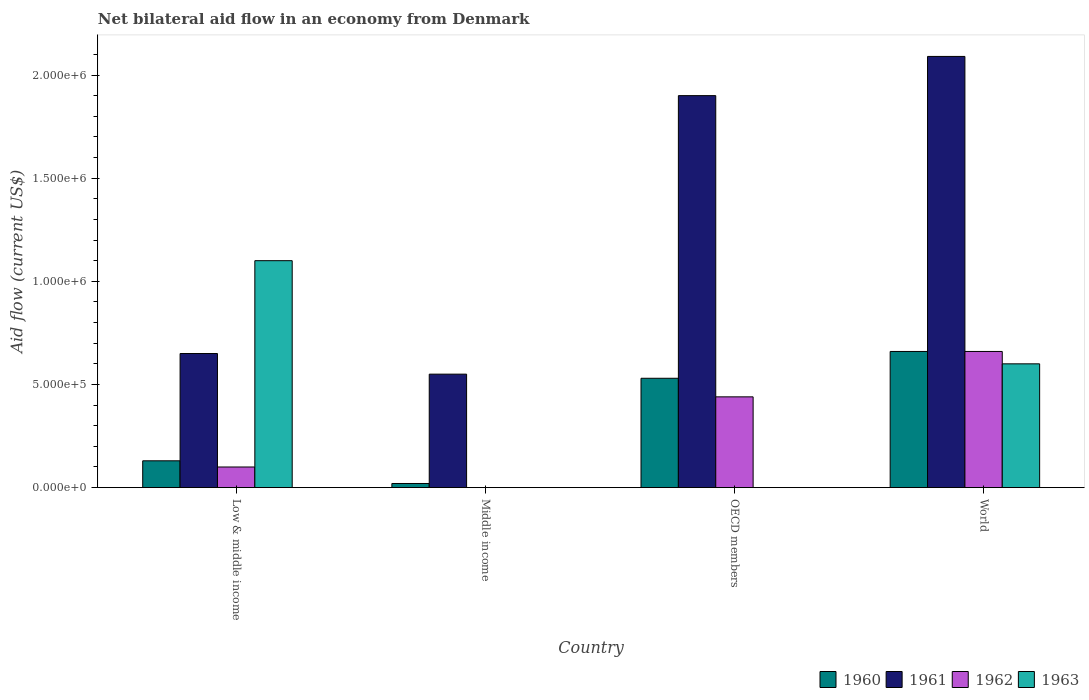How many different coloured bars are there?
Your answer should be very brief. 4. How many groups of bars are there?
Offer a terse response. 4. Are the number of bars per tick equal to the number of legend labels?
Ensure brevity in your answer.  No. Are the number of bars on each tick of the X-axis equal?
Provide a short and direct response. No. How many bars are there on the 3rd tick from the right?
Offer a terse response. 2. What is the label of the 2nd group of bars from the left?
Provide a short and direct response. Middle income. What is the net bilateral aid flow in 1963 in World?
Provide a succinct answer. 6.00e+05. Across all countries, what is the maximum net bilateral aid flow in 1963?
Provide a succinct answer. 1.10e+06. In which country was the net bilateral aid flow in 1960 maximum?
Your response must be concise. World. What is the total net bilateral aid flow in 1961 in the graph?
Ensure brevity in your answer.  5.19e+06. What is the difference between the net bilateral aid flow in 1960 in Low & middle income and that in OECD members?
Your response must be concise. -4.00e+05. What is the difference between the net bilateral aid flow in 1962 in Low & middle income and the net bilateral aid flow in 1963 in World?
Give a very brief answer. -5.00e+05. What is the difference between the net bilateral aid flow of/in 1962 and net bilateral aid flow of/in 1960 in OECD members?
Provide a short and direct response. -9.00e+04. In how many countries, is the net bilateral aid flow in 1962 greater than 600000 US$?
Your answer should be very brief. 1. What is the ratio of the net bilateral aid flow in 1961 in Middle income to that in OECD members?
Offer a very short reply. 0.29. What is the difference between the highest and the second highest net bilateral aid flow in 1960?
Keep it short and to the point. 1.30e+05. What is the difference between the highest and the lowest net bilateral aid flow in 1961?
Keep it short and to the point. 1.54e+06. In how many countries, is the net bilateral aid flow in 1961 greater than the average net bilateral aid flow in 1961 taken over all countries?
Keep it short and to the point. 2. Is the sum of the net bilateral aid flow in 1960 in Low & middle income and OECD members greater than the maximum net bilateral aid flow in 1963 across all countries?
Ensure brevity in your answer.  No. How many bars are there?
Provide a succinct answer. 13. Are all the bars in the graph horizontal?
Offer a terse response. No. How many countries are there in the graph?
Keep it short and to the point. 4. What is the difference between two consecutive major ticks on the Y-axis?
Your response must be concise. 5.00e+05. How are the legend labels stacked?
Offer a very short reply. Horizontal. What is the title of the graph?
Make the answer very short. Net bilateral aid flow in an economy from Denmark. What is the label or title of the Y-axis?
Offer a very short reply. Aid flow (current US$). What is the Aid flow (current US$) of 1960 in Low & middle income?
Ensure brevity in your answer.  1.30e+05. What is the Aid flow (current US$) of 1961 in Low & middle income?
Provide a succinct answer. 6.50e+05. What is the Aid flow (current US$) of 1963 in Low & middle income?
Offer a very short reply. 1.10e+06. What is the Aid flow (current US$) in 1960 in Middle income?
Give a very brief answer. 2.00e+04. What is the Aid flow (current US$) of 1961 in Middle income?
Make the answer very short. 5.50e+05. What is the Aid flow (current US$) in 1962 in Middle income?
Offer a very short reply. 0. What is the Aid flow (current US$) of 1960 in OECD members?
Provide a succinct answer. 5.30e+05. What is the Aid flow (current US$) of 1961 in OECD members?
Your answer should be compact. 1.90e+06. What is the Aid flow (current US$) in 1963 in OECD members?
Provide a short and direct response. 0. What is the Aid flow (current US$) of 1960 in World?
Your answer should be very brief. 6.60e+05. What is the Aid flow (current US$) of 1961 in World?
Ensure brevity in your answer.  2.09e+06. What is the Aid flow (current US$) in 1962 in World?
Offer a terse response. 6.60e+05. What is the Aid flow (current US$) in 1963 in World?
Your answer should be compact. 6.00e+05. Across all countries, what is the maximum Aid flow (current US$) in 1961?
Your answer should be compact. 2.09e+06. Across all countries, what is the maximum Aid flow (current US$) in 1963?
Make the answer very short. 1.10e+06. Across all countries, what is the minimum Aid flow (current US$) in 1961?
Provide a succinct answer. 5.50e+05. Across all countries, what is the minimum Aid flow (current US$) of 1962?
Offer a terse response. 0. What is the total Aid flow (current US$) in 1960 in the graph?
Provide a short and direct response. 1.34e+06. What is the total Aid flow (current US$) of 1961 in the graph?
Provide a succinct answer. 5.19e+06. What is the total Aid flow (current US$) in 1962 in the graph?
Your answer should be very brief. 1.20e+06. What is the total Aid flow (current US$) in 1963 in the graph?
Offer a terse response. 1.70e+06. What is the difference between the Aid flow (current US$) of 1961 in Low & middle income and that in Middle income?
Offer a terse response. 1.00e+05. What is the difference between the Aid flow (current US$) in 1960 in Low & middle income and that in OECD members?
Keep it short and to the point. -4.00e+05. What is the difference between the Aid flow (current US$) in 1961 in Low & middle income and that in OECD members?
Make the answer very short. -1.25e+06. What is the difference between the Aid flow (current US$) of 1960 in Low & middle income and that in World?
Your answer should be compact. -5.30e+05. What is the difference between the Aid flow (current US$) of 1961 in Low & middle income and that in World?
Your answer should be compact. -1.44e+06. What is the difference between the Aid flow (current US$) of 1962 in Low & middle income and that in World?
Give a very brief answer. -5.60e+05. What is the difference between the Aid flow (current US$) of 1960 in Middle income and that in OECD members?
Ensure brevity in your answer.  -5.10e+05. What is the difference between the Aid flow (current US$) in 1961 in Middle income and that in OECD members?
Give a very brief answer. -1.35e+06. What is the difference between the Aid flow (current US$) of 1960 in Middle income and that in World?
Your answer should be very brief. -6.40e+05. What is the difference between the Aid flow (current US$) in 1961 in Middle income and that in World?
Keep it short and to the point. -1.54e+06. What is the difference between the Aid flow (current US$) of 1960 in Low & middle income and the Aid flow (current US$) of 1961 in Middle income?
Provide a short and direct response. -4.20e+05. What is the difference between the Aid flow (current US$) in 1960 in Low & middle income and the Aid flow (current US$) in 1961 in OECD members?
Your answer should be very brief. -1.77e+06. What is the difference between the Aid flow (current US$) of 1960 in Low & middle income and the Aid flow (current US$) of 1962 in OECD members?
Offer a very short reply. -3.10e+05. What is the difference between the Aid flow (current US$) in 1960 in Low & middle income and the Aid flow (current US$) in 1961 in World?
Offer a terse response. -1.96e+06. What is the difference between the Aid flow (current US$) in 1960 in Low & middle income and the Aid flow (current US$) in 1962 in World?
Your answer should be compact. -5.30e+05. What is the difference between the Aid flow (current US$) in 1960 in Low & middle income and the Aid flow (current US$) in 1963 in World?
Provide a short and direct response. -4.70e+05. What is the difference between the Aid flow (current US$) in 1961 in Low & middle income and the Aid flow (current US$) in 1963 in World?
Give a very brief answer. 5.00e+04. What is the difference between the Aid flow (current US$) of 1962 in Low & middle income and the Aid flow (current US$) of 1963 in World?
Keep it short and to the point. -5.00e+05. What is the difference between the Aid flow (current US$) in 1960 in Middle income and the Aid flow (current US$) in 1961 in OECD members?
Keep it short and to the point. -1.88e+06. What is the difference between the Aid flow (current US$) of 1960 in Middle income and the Aid flow (current US$) of 1962 in OECD members?
Your answer should be compact. -4.20e+05. What is the difference between the Aid flow (current US$) of 1961 in Middle income and the Aid flow (current US$) of 1962 in OECD members?
Make the answer very short. 1.10e+05. What is the difference between the Aid flow (current US$) of 1960 in Middle income and the Aid flow (current US$) of 1961 in World?
Keep it short and to the point. -2.07e+06. What is the difference between the Aid flow (current US$) of 1960 in Middle income and the Aid flow (current US$) of 1962 in World?
Your answer should be very brief. -6.40e+05. What is the difference between the Aid flow (current US$) of 1960 in Middle income and the Aid flow (current US$) of 1963 in World?
Offer a terse response. -5.80e+05. What is the difference between the Aid flow (current US$) in 1961 in Middle income and the Aid flow (current US$) in 1963 in World?
Provide a succinct answer. -5.00e+04. What is the difference between the Aid flow (current US$) of 1960 in OECD members and the Aid flow (current US$) of 1961 in World?
Your answer should be compact. -1.56e+06. What is the difference between the Aid flow (current US$) of 1960 in OECD members and the Aid flow (current US$) of 1962 in World?
Ensure brevity in your answer.  -1.30e+05. What is the difference between the Aid flow (current US$) in 1960 in OECD members and the Aid flow (current US$) in 1963 in World?
Your answer should be compact. -7.00e+04. What is the difference between the Aid flow (current US$) in 1961 in OECD members and the Aid flow (current US$) in 1962 in World?
Keep it short and to the point. 1.24e+06. What is the difference between the Aid flow (current US$) of 1961 in OECD members and the Aid flow (current US$) of 1963 in World?
Give a very brief answer. 1.30e+06. What is the average Aid flow (current US$) in 1960 per country?
Give a very brief answer. 3.35e+05. What is the average Aid flow (current US$) in 1961 per country?
Your response must be concise. 1.30e+06. What is the average Aid flow (current US$) of 1963 per country?
Keep it short and to the point. 4.25e+05. What is the difference between the Aid flow (current US$) of 1960 and Aid flow (current US$) of 1961 in Low & middle income?
Make the answer very short. -5.20e+05. What is the difference between the Aid flow (current US$) in 1960 and Aid flow (current US$) in 1963 in Low & middle income?
Your answer should be very brief. -9.70e+05. What is the difference between the Aid flow (current US$) of 1961 and Aid flow (current US$) of 1963 in Low & middle income?
Offer a very short reply. -4.50e+05. What is the difference between the Aid flow (current US$) in 1960 and Aid flow (current US$) in 1961 in Middle income?
Offer a terse response. -5.30e+05. What is the difference between the Aid flow (current US$) in 1960 and Aid flow (current US$) in 1961 in OECD members?
Provide a short and direct response. -1.37e+06. What is the difference between the Aid flow (current US$) in 1961 and Aid flow (current US$) in 1962 in OECD members?
Your answer should be compact. 1.46e+06. What is the difference between the Aid flow (current US$) of 1960 and Aid flow (current US$) of 1961 in World?
Provide a succinct answer. -1.43e+06. What is the difference between the Aid flow (current US$) in 1960 and Aid flow (current US$) in 1962 in World?
Give a very brief answer. 0. What is the difference between the Aid flow (current US$) of 1961 and Aid flow (current US$) of 1962 in World?
Keep it short and to the point. 1.43e+06. What is the difference between the Aid flow (current US$) of 1961 and Aid flow (current US$) of 1963 in World?
Give a very brief answer. 1.49e+06. What is the ratio of the Aid flow (current US$) in 1960 in Low & middle income to that in Middle income?
Provide a short and direct response. 6.5. What is the ratio of the Aid flow (current US$) in 1961 in Low & middle income to that in Middle income?
Give a very brief answer. 1.18. What is the ratio of the Aid flow (current US$) in 1960 in Low & middle income to that in OECD members?
Your answer should be compact. 0.25. What is the ratio of the Aid flow (current US$) in 1961 in Low & middle income to that in OECD members?
Ensure brevity in your answer.  0.34. What is the ratio of the Aid flow (current US$) in 1962 in Low & middle income to that in OECD members?
Ensure brevity in your answer.  0.23. What is the ratio of the Aid flow (current US$) of 1960 in Low & middle income to that in World?
Your answer should be very brief. 0.2. What is the ratio of the Aid flow (current US$) of 1961 in Low & middle income to that in World?
Offer a very short reply. 0.31. What is the ratio of the Aid flow (current US$) in 1962 in Low & middle income to that in World?
Keep it short and to the point. 0.15. What is the ratio of the Aid flow (current US$) in 1963 in Low & middle income to that in World?
Your response must be concise. 1.83. What is the ratio of the Aid flow (current US$) in 1960 in Middle income to that in OECD members?
Offer a very short reply. 0.04. What is the ratio of the Aid flow (current US$) of 1961 in Middle income to that in OECD members?
Give a very brief answer. 0.29. What is the ratio of the Aid flow (current US$) in 1960 in Middle income to that in World?
Provide a short and direct response. 0.03. What is the ratio of the Aid flow (current US$) in 1961 in Middle income to that in World?
Provide a short and direct response. 0.26. What is the ratio of the Aid flow (current US$) in 1960 in OECD members to that in World?
Provide a short and direct response. 0.8. What is the ratio of the Aid flow (current US$) of 1961 in OECD members to that in World?
Offer a terse response. 0.91. What is the ratio of the Aid flow (current US$) of 1962 in OECD members to that in World?
Make the answer very short. 0.67. What is the difference between the highest and the second highest Aid flow (current US$) in 1960?
Your answer should be very brief. 1.30e+05. What is the difference between the highest and the second highest Aid flow (current US$) of 1962?
Your answer should be very brief. 2.20e+05. What is the difference between the highest and the lowest Aid flow (current US$) of 1960?
Your response must be concise. 6.40e+05. What is the difference between the highest and the lowest Aid flow (current US$) in 1961?
Ensure brevity in your answer.  1.54e+06. What is the difference between the highest and the lowest Aid flow (current US$) in 1962?
Offer a terse response. 6.60e+05. What is the difference between the highest and the lowest Aid flow (current US$) of 1963?
Offer a very short reply. 1.10e+06. 